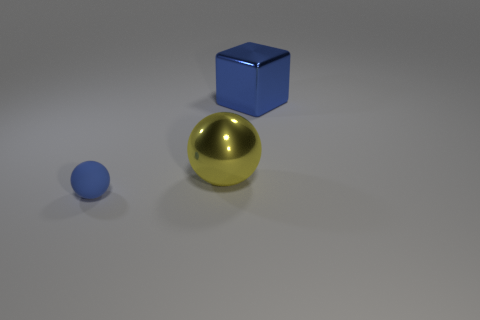What material does the shiny sphere seem to be made of? The shiny sphere has a reflective surface that suggests it could be made of a polished metal, possibly resembling materials like steel or chrome because of its mirror-like finish. 